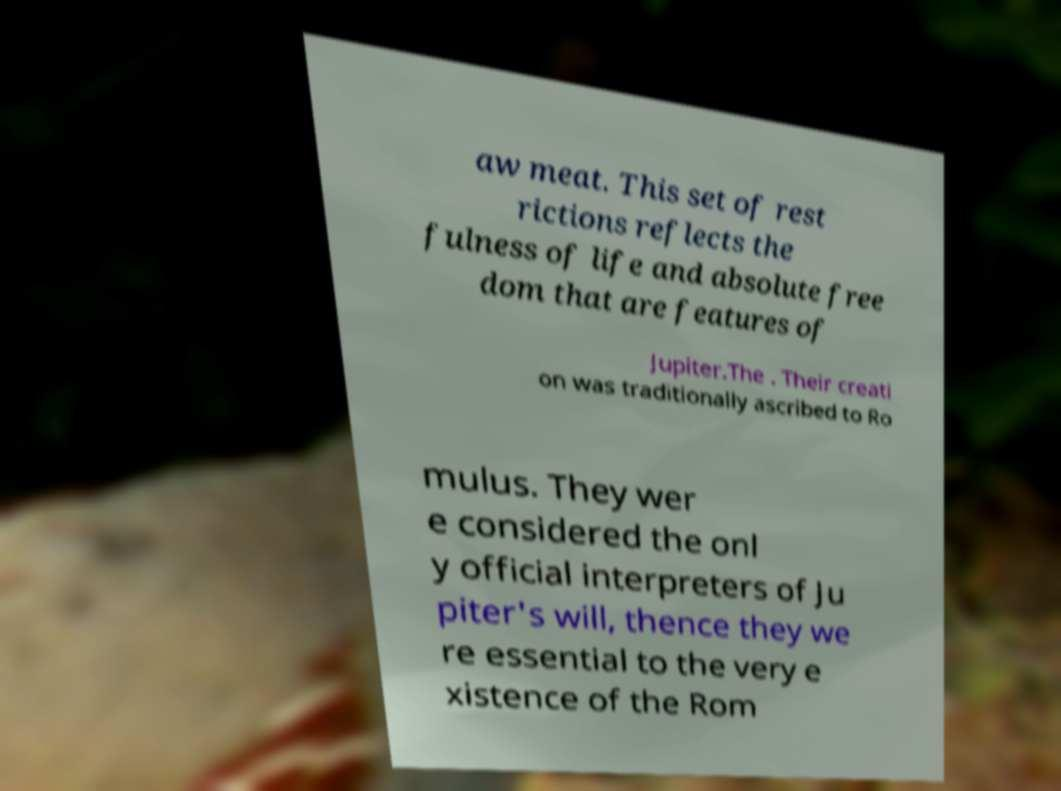What messages or text are displayed in this image? I need them in a readable, typed format. aw meat. This set of rest rictions reflects the fulness of life and absolute free dom that are features of Jupiter.The . Their creati on was traditionally ascribed to Ro mulus. They wer e considered the onl y official interpreters of Ju piter's will, thence they we re essential to the very e xistence of the Rom 